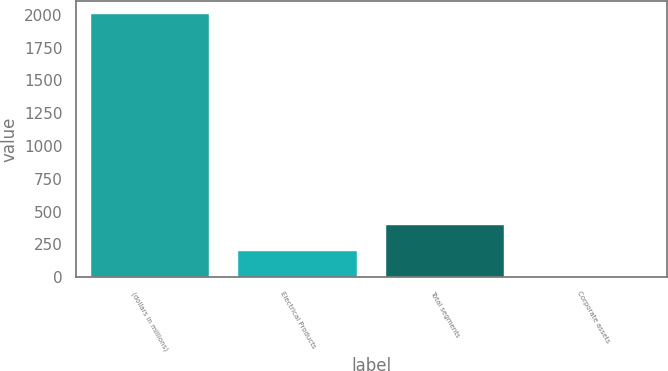Convert chart to OTSL. <chart><loc_0><loc_0><loc_500><loc_500><bar_chart><fcel>(dollars in millions)<fcel>Electrical Products<fcel>Total segments<fcel>Corporate assets<nl><fcel>2005<fcel>200.77<fcel>401.24<fcel>0.3<nl></chart> 